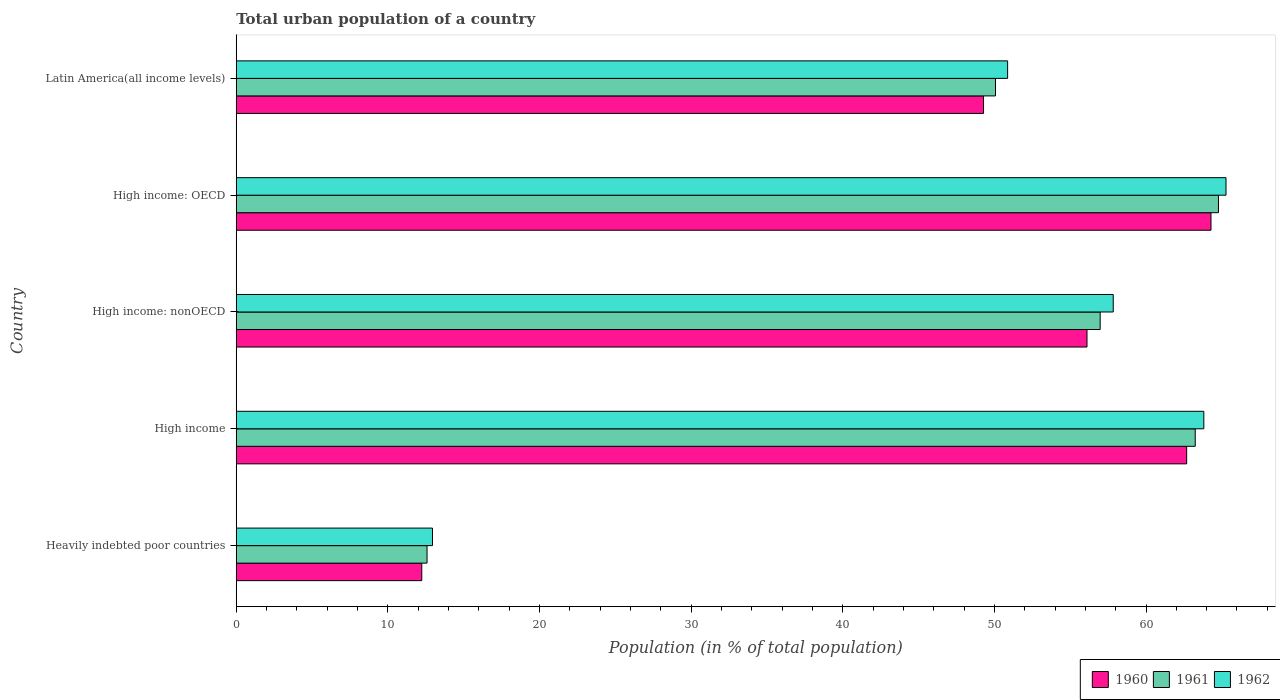How many groups of bars are there?
Offer a terse response. 5. Are the number of bars per tick equal to the number of legend labels?
Ensure brevity in your answer.  Yes. How many bars are there on the 1st tick from the top?
Offer a very short reply. 3. What is the label of the 2nd group of bars from the top?
Keep it short and to the point. High income: OECD. In how many cases, is the number of bars for a given country not equal to the number of legend labels?
Your answer should be compact. 0. What is the urban population in 1962 in Latin America(all income levels)?
Provide a short and direct response. 50.87. Across all countries, what is the maximum urban population in 1961?
Keep it short and to the point. 64.78. Across all countries, what is the minimum urban population in 1961?
Your response must be concise. 12.58. In which country was the urban population in 1960 maximum?
Provide a succinct answer. High income: OECD. In which country was the urban population in 1962 minimum?
Your answer should be very brief. Heavily indebted poor countries. What is the total urban population in 1960 in the graph?
Make the answer very short. 244.59. What is the difference between the urban population in 1961 in High income: nonOECD and that in Latin America(all income levels)?
Give a very brief answer. 6.9. What is the difference between the urban population in 1962 in Heavily indebted poor countries and the urban population in 1960 in High income: nonOECD?
Ensure brevity in your answer.  -43.17. What is the average urban population in 1961 per country?
Your response must be concise. 49.53. What is the difference between the urban population in 1962 and urban population in 1961 in High income: OECD?
Your answer should be very brief. 0.5. What is the ratio of the urban population in 1961 in Heavily indebted poor countries to that in Latin America(all income levels)?
Give a very brief answer. 0.25. Is the urban population in 1960 in High income less than that in High income: OECD?
Ensure brevity in your answer.  Yes. What is the difference between the highest and the second highest urban population in 1960?
Provide a short and direct response. 1.61. What is the difference between the highest and the lowest urban population in 1961?
Provide a short and direct response. 52.2. Is the sum of the urban population in 1962 in Heavily indebted poor countries and High income: nonOECD greater than the maximum urban population in 1960 across all countries?
Offer a very short reply. Yes. Is it the case that in every country, the sum of the urban population in 1962 and urban population in 1960 is greater than the urban population in 1961?
Provide a short and direct response. Yes. Are all the bars in the graph horizontal?
Offer a very short reply. Yes. How many countries are there in the graph?
Provide a short and direct response. 5. Are the values on the major ticks of X-axis written in scientific E-notation?
Ensure brevity in your answer.  No. Does the graph contain grids?
Your answer should be compact. No. Where does the legend appear in the graph?
Offer a very short reply. Bottom right. What is the title of the graph?
Keep it short and to the point. Total urban population of a country. What is the label or title of the X-axis?
Provide a short and direct response. Population (in % of total population). What is the label or title of the Y-axis?
Your answer should be compact. Country. What is the Population (in % of total population) of 1960 in Heavily indebted poor countries?
Give a very brief answer. 12.24. What is the Population (in % of total population) of 1961 in Heavily indebted poor countries?
Provide a short and direct response. 12.58. What is the Population (in % of total population) of 1962 in Heavily indebted poor countries?
Your answer should be very brief. 12.94. What is the Population (in % of total population) of 1960 in High income?
Offer a very short reply. 62.68. What is the Population (in % of total population) in 1961 in High income?
Keep it short and to the point. 63.25. What is the Population (in % of total population) in 1962 in High income?
Ensure brevity in your answer.  63.81. What is the Population (in % of total population) in 1960 in High income: nonOECD?
Offer a very short reply. 56.11. What is the Population (in % of total population) of 1961 in High income: nonOECD?
Your answer should be compact. 56.98. What is the Population (in % of total population) in 1962 in High income: nonOECD?
Your response must be concise. 57.84. What is the Population (in % of total population) of 1960 in High income: OECD?
Provide a short and direct response. 64.29. What is the Population (in % of total population) of 1961 in High income: OECD?
Make the answer very short. 64.78. What is the Population (in % of total population) of 1962 in High income: OECD?
Offer a very short reply. 65.28. What is the Population (in % of total population) of 1960 in Latin America(all income levels)?
Provide a short and direct response. 49.28. What is the Population (in % of total population) in 1961 in Latin America(all income levels)?
Make the answer very short. 50.07. What is the Population (in % of total population) of 1962 in Latin America(all income levels)?
Offer a terse response. 50.87. Across all countries, what is the maximum Population (in % of total population) in 1960?
Ensure brevity in your answer.  64.29. Across all countries, what is the maximum Population (in % of total population) of 1961?
Offer a terse response. 64.78. Across all countries, what is the maximum Population (in % of total population) in 1962?
Ensure brevity in your answer.  65.28. Across all countries, what is the minimum Population (in % of total population) in 1960?
Ensure brevity in your answer.  12.24. Across all countries, what is the minimum Population (in % of total population) of 1961?
Your answer should be very brief. 12.58. Across all countries, what is the minimum Population (in % of total population) of 1962?
Give a very brief answer. 12.94. What is the total Population (in % of total population) of 1960 in the graph?
Offer a terse response. 244.59. What is the total Population (in % of total population) in 1961 in the graph?
Give a very brief answer. 247.66. What is the total Population (in % of total population) in 1962 in the graph?
Make the answer very short. 250.74. What is the difference between the Population (in % of total population) of 1960 in Heavily indebted poor countries and that in High income?
Provide a short and direct response. -50.44. What is the difference between the Population (in % of total population) of 1961 in Heavily indebted poor countries and that in High income?
Your answer should be very brief. -50.66. What is the difference between the Population (in % of total population) in 1962 in Heavily indebted poor countries and that in High income?
Ensure brevity in your answer.  -50.87. What is the difference between the Population (in % of total population) of 1960 in Heavily indebted poor countries and that in High income: nonOECD?
Provide a short and direct response. -43.87. What is the difference between the Population (in % of total population) of 1961 in Heavily indebted poor countries and that in High income: nonOECD?
Offer a terse response. -44.39. What is the difference between the Population (in % of total population) in 1962 in Heavily indebted poor countries and that in High income: nonOECD?
Your answer should be very brief. -44.9. What is the difference between the Population (in % of total population) in 1960 in Heavily indebted poor countries and that in High income: OECD?
Make the answer very short. -52.05. What is the difference between the Population (in % of total population) of 1961 in Heavily indebted poor countries and that in High income: OECD?
Your response must be concise. -52.2. What is the difference between the Population (in % of total population) in 1962 in Heavily indebted poor countries and that in High income: OECD?
Make the answer very short. -52.33. What is the difference between the Population (in % of total population) of 1960 in Heavily indebted poor countries and that in Latin America(all income levels)?
Offer a terse response. -37.05. What is the difference between the Population (in % of total population) in 1961 in Heavily indebted poor countries and that in Latin America(all income levels)?
Your answer should be very brief. -37.49. What is the difference between the Population (in % of total population) of 1962 in Heavily indebted poor countries and that in Latin America(all income levels)?
Keep it short and to the point. -37.93. What is the difference between the Population (in % of total population) of 1960 in High income and that in High income: nonOECD?
Offer a very short reply. 6.57. What is the difference between the Population (in % of total population) in 1961 in High income and that in High income: nonOECD?
Keep it short and to the point. 6.27. What is the difference between the Population (in % of total population) in 1962 in High income and that in High income: nonOECD?
Offer a terse response. 5.97. What is the difference between the Population (in % of total population) in 1960 in High income and that in High income: OECD?
Give a very brief answer. -1.61. What is the difference between the Population (in % of total population) of 1961 in High income and that in High income: OECD?
Make the answer very short. -1.53. What is the difference between the Population (in % of total population) in 1962 in High income and that in High income: OECD?
Make the answer very short. -1.46. What is the difference between the Population (in % of total population) of 1960 in High income and that in Latin America(all income levels)?
Make the answer very short. 13.4. What is the difference between the Population (in % of total population) in 1961 in High income and that in Latin America(all income levels)?
Give a very brief answer. 13.17. What is the difference between the Population (in % of total population) of 1962 in High income and that in Latin America(all income levels)?
Give a very brief answer. 12.94. What is the difference between the Population (in % of total population) of 1960 in High income: nonOECD and that in High income: OECD?
Your answer should be very brief. -8.18. What is the difference between the Population (in % of total population) in 1961 in High income: nonOECD and that in High income: OECD?
Provide a short and direct response. -7.8. What is the difference between the Population (in % of total population) in 1962 in High income: nonOECD and that in High income: OECD?
Ensure brevity in your answer.  -7.44. What is the difference between the Population (in % of total population) of 1960 in High income: nonOECD and that in Latin America(all income levels)?
Your response must be concise. 6.82. What is the difference between the Population (in % of total population) of 1961 in High income: nonOECD and that in Latin America(all income levels)?
Your answer should be very brief. 6.9. What is the difference between the Population (in % of total population) in 1962 in High income: nonOECD and that in Latin America(all income levels)?
Provide a succinct answer. 6.97. What is the difference between the Population (in % of total population) of 1960 in High income: OECD and that in Latin America(all income levels)?
Your response must be concise. 15. What is the difference between the Population (in % of total population) in 1961 in High income: OECD and that in Latin America(all income levels)?
Ensure brevity in your answer.  14.71. What is the difference between the Population (in % of total population) in 1962 in High income: OECD and that in Latin America(all income levels)?
Give a very brief answer. 14.4. What is the difference between the Population (in % of total population) of 1960 in Heavily indebted poor countries and the Population (in % of total population) of 1961 in High income?
Keep it short and to the point. -51.01. What is the difference between the Population (in % of total population) of 1960 in Heavily indebted poor countries and the Population (in % of total population) of 1962 in High income?
Your answer should be very brief. -51.58. What is the difference between the Population (in % of total population) in 1961 in Heavily indebted poor countries and the Population (in % of total population) in 1962 in High income?
Provide a succinct answer. -51.23. What is the difference between the Population (in % of total population) in 1960 in Heavily indebted poor countries and the Population (in % of total population) in 1961 in High income: nonOECD?
Make the answer very short. -44.74. What is the difference between the Population (in % of total population) of 1960 in Heavily indebted poor countries and the Population (in % of total population) of 1962 in High income: nonOECD?
Offer a very short reply. -45.6. What is the difference between the Population (in % of total population) in 1961 in Heavily indebted poor countries and the Population (in % of total population) in 1962 in High income: nonOECD?
Make the answer very short. -45.26. What is the difference between the Population (in % of total population) in 1960 in Heavily indebted poor countries and the Population (in % of total population) in 1961 in High income: OECD?
Give a very brief answer. -52.54. What is the difference between the Population (in % of total population) of 1960 in Heavily indebted poor countries and the Population (in % of total population) of 1962 in High income: OECD?
Ensure brevity in your answer.  -53.04. What is the difference between the Population (in % of total population) of 1961 in Heavily indebted poor countries and the Population (in % of total population) of 1962 in High income: OECD?
Your answer should be compact. -52.69. What is the difference between the Population (in % of total population) in 1960 in Heavily indebted poor countries and the Population (in % of total population) in 1961 in Latin America(all income levels)?
Provide a succinct answer. -37.84. What is the difference between the Population (in % of total population) of 1960 in Heavily indebted poor countries and the Population (in % of total population) of 1962 in Latin America(all income levels)?
Keep it short and to the point. -38.64. What is the difference between the Population (in % of total population) in 1961 in Heavily indebted poor countries and the Population (in % of total population) in 1962 in Latin America(all income levels)?
Offer a very short reply. -38.29. What is the difference between the Population (in % of total population) in 1960 in High income and the Population (in % of total population) in 1961 in High income: nonOECD?
Your response must be concise. 5.7. What is the difference between the Population (in % of total population) in 1960 in High income and the Population (in % of total population) in 1962 in High income: nonOECD?
Your response must be concise. 4.84. What is the difference between the Population (in % of total population) of 1961 in High income and the Population (in % of total population) of 1962 in High income: nonOECD?
Provide a short and direct response. 5.41. What is the difference between the Population (in % of total population) of 1960 in High income and the Population (in % of total population) of 1961 in High income: OECD?
Keep it short and to the point. -2.1. What is the difference between the Population (in % of total population) in 1960 in High income and the Population (in % of total population) in 1962 in High income: OECD?
Give a very brief answer. -2.6. What is the difference between the Population (in % of total population) of 1961 in High income and the Population (in % of total population) of 1962 in High income: OECD?
Provide a short and direct response. -2.03. What is the difference between the Population (in % of total population) of 1960 in High income and the Population (in % of total population) of 1961 in Latin America(all income levels)?
Ensure brevity in your answer.  12.61. What is the difference between the Population (in % of total population) in 1960 in High income and the Population (in % of total population) in 1962 in Latin America(all income levels)?
Provide a succinct answer. 11.81. What is the difference between the Population (in % of total population) of 1961 in High income and the Population (in % of total population) of 1962 in Latin America(all income levels)?
Ensure brevity in your answer.  12.37. What is the difference between the Population (in % of total population) in 1960 in High income: nonOECD and the Population (in % of total population) in 1961 in High income: OECD?
Provide a short and direct response. -8.67. What is the difference between the Population (in % of total population) in 1960 in High income: nonOECD and the Population (in % of total population) in 1962 in High income: OECD?
Offer a very short reply. -9.17. What is the difference between the Population (in % of total population) of 1961 in High income: nonOECD and the Population (in % of total population) of 1962 in High income: OECD?
Ensure brevity in your answer.  -8.3. What is the difference between the Population (in % of total population) of 1960 in High income: nonOECD and the Population (in % of total population) of 1961 in Latin America(all income levels)?
Offer a terse response. 6.03. What is the difference between the Population (in % of total population) of 1960 in High income: nonOECD and the Population (in % of total population) of 1962 in Latin America(all income levels)?
Offer a terse response. 5.24. What is the difference between the Population (in % of total population) in 1961 in High income: nonOECD and the Population (in % of total population) in 1962 in Latin America(all income levels)?
Give a very brief answer. 6.1. What is the difference between the Population (in % of total population) in 1960 in High income: OECD and the Population (in % of total population) in 1961 in Latin America(all income levels)?
Offer a very short reply. 14.21. What is the difference between the Population (in % of total population) in 1960 in High income: OECD and the Population (in % of total population) in 1962 in Latin America(all income levels)?
Provide a short and direct response. 13.41. What is the difference between the Population (in % of total population) in 1961 in High income: OECD and the Population (in % of total population) in 1962 in Latin America(all income levels)?
Make the answer very short. 13.91. What is the average Population (in % of total population) of 1960 per country?
Make the answer very short. 48.92. What is the average Population (in % of total population) in 1961 per country?
Ensure brevity in your answer.  49.53. What is the average Population (in % of total population) of 1962 per country?
Make the answer very short. 50.15. What is the difference between the Population (in % of total population) of 1960 and Population (in % of total population) of 1961 in Heavily indebted poor countries?
Provide a succinct answer. -0.35. What is the difference between the Population (in % of total population) of 1960 and Population (in % of total population) of 1962 in Heavily indebted poor countries?
Your response must be concise. -0.71. What is the difference between the Population (in % of total population) of 1961 and Population (in % of total population) of 1962 in Heavily indebted poor countries?
Offer a very short reply. -0.36. What is the difference between the Population (in % of total population) in 1960 and Population (in % of total population) in 1961 in High income?
Make the answer very short. -0.57. What is the difference between the Population (in % of total population) of 1960 and Population (in % of total population) of 1962 in High income?
Give a very brief answer. -1.13. What is the difference between the Population (in % of total population) in 1961 and Population (in % of total population) in 1962 in High income?
Keep it short and to the point. -0.57. What is the difference between the Population (in % of total population) of 1960 and Population (in % of total population) of 1961 in High income: nonOECD?
Provide a succinct answer. -0.87. What is the difference between the Population (in % of total population) of 1960 and Population (in % of total population) of 1962 in High income: nonOECD?
Give a very brief answer. -1.73. What is the difference between the Population (in % of total population) of 1961 and Population (in % of total population) of 1962 in High income: nonOECD?
Provide a short and direct response. -0.86. What is the difference between the Population (in % of total population) of 1960 and Population (in % of total population) of 1961 in High income: OECD?
Provide a short and direct response. -0.49. What is the difference between the Population (in % of total population) of 1960 and Population (in % of total population) of 1962 in High income: OECD?
Offer a very short reply. -0.99. What is the difference between the Population (in % of total population) of 1961 and Population (in % of total population) of 1962 in High income: OECD?
Your answer should be very brief. -0.5. What is the difference between the Population (in % of total population) of 1960 and Population (in % of total population) of 1961 in Latin America(all income levels)?
Make the answer very short. -0.79. What is the difference between the Population (in % of total population) in 1960 and Population (in % of total population) in 1962 in Latin America(all income levels)?
Make the answer very short. -1.59. What is the difference between the Population (in % of total population) of 1961 and Population (in % of total population) of 1962 in Latin America(all income levels)?
Your answer should be very brief. -0.8. What is the ratio of the Population (in % of total population) of 1960 in Heavily indebted poor countries to that in High income?
Ensure brevity in your answer.  0.2. What is the ratio of the Population (in % of total population) in 1961 in Heavily indebted poor countries to that in High income?
Provide a succinct answer. 0.2. What is the ratio of the Population (in % of total population) in 1962 in Heavily indebted poor countries to that in High income?
Offer a very short reply. 0.2. What is the ratio of the Population (in % of total population) in 1960 in Heavily indebted poor countries to that in High income: nonOECD?
Keep it short and to the point. 0.22. What is the ratio of the Population (in % of total population) in 1961 in Heavily indebted poor countries to that in High income: nonOECD?
Offer a terse response. 0.22. What is the ratio of the Population (in % of total population) in 1962 in Heavily indebted poor countries to that in High income: nonOECD?
Make the answer very short. 0.22. What is the ratio of the Population (in % of total population) of 1960 in Heavily indebted poor countries to that in High income: OECD?
Keep it short and to the point. 0.19. What is the ratio of the Population (in % of total population) in 1961 in Heavily indebted poor countries to that in High income: OECD?
Keep it short and to the point. 0.19. What is the ratio of the Population (in % of total population) of 1962 in Heavily indebted poor countries to that in High income: OECD?
Offer a very short reply. 0.2. What is the ratio of the Population (in % of total population) of 1960 in Heavily indebted poor countries to that in Latin America(all income levels)?
Provide a short and direct response. 0.25. What is the ratio of the Population (in % of total population) of 1961 in Heavily indebted poor countries to that in Latin America(all income levels)?
Make the answer very short. 0.25. What is the ratio of the Population (in % of total population) in 1962 in Heavily indebted poor countries to that in Latin America(all income levels)?
Provide a succinct answer. 0.25. What is the ratio of the Population (in % of total population) in 1960 in High income to that in High income: nonOECD?
Provide a succinct answer. 1.12. What is the ratio of the Population (in % of total population) in 1961 in High income to that in High income: nonOECD?
Your answer should be compact. 1.11. What is the ratio of the Population (in % of total population) in 1962 in High income to that in High income: nonOECD?
Your answer should be compact. 1.1. What is the ratio of the Population (in % of total population) in 1960 in High income to that in High income: OECD?
Make the answer very short. 0.97. What is the ratio of the Population (in % of total population) in 1961 in High income to that in High income: OECD?
Your response must be concise. 0.98. What is the ratio of the Population (in % of total population) in 1962 in High income to that in High income: OECD?
Your response must be concise. 0.98. What is the ratio of the Population (in % of total population) in 1960 in High income to that in Latin America(all income levels)?
Offer a terse response. 1.27. What is the ratio of the Population (in % of total population) of 1961 in High income to that in Latin America(all income levels)?
Your answer should be compact. 1.26. What is the ratio of the Population (in % of total population) in 1962 in High income to that in Latin America(all income levels)?
Your response must be concise. 1.25. What is the ratio of the Population (in % of total population) in 1960 in High income: nonOECD to that in High income: OECD?
Ensure brevity in your answer.  0.87. What is the ratio of the Population (in % of total population) in 1961 in High income: nonOECD to that in High income: OECD?
Give a very brief answer. 0.88. What is the ratio of the Population (in % of total population) in 1962 in High income: nonOECD to that in High income: OECD?
Offer a very short reply. 0.89. What is the ratio of the Population (in % of total population) of 1960 in High income: nonOECD to that in Latin America(all income levels)?
Your answer should be compact. 1.14. What is the ratio of the Population (in % of total population) in 1961 in High income: nonOECD to that in Latin America(all income levels)?
Provide a succinct answer. 1.14. What is the ratio of the Population (in % of total population) of 1962 in High income: nonOECD to that in Latin America(all income levels)?
Make the answer very short. 1.14. What is the ratio of the Population (in % of total population) of 1960 in High income: OECD to that in Latin America(all income levels)?
Give a very brief answer. 1.3. What is the ratio of the Population (in % of total population) of 1961 in High income: OECD to that in Latin America(all income levels)?
Ensure brevity in your answer.  1.29. What is the ratio of the Population (in % of total population) of 1962 in High income: OECD to that in Latin America(all income levels)?
Provide a succinct answer. 1.28. What is the difference between the highest and the second highest Population (in % of total population) in 1960?
Give a very brief answer. 1.61. What is the difference between the highest and the second highest Population (in % of total population) in 1961?
Provide a succinct answer. 1.53. What is the difference between the highest and the second highest Population (in % of total population) in 1962?
Provide a succinct answer. 1.46. What is the difference between the highest and the lowest Population (in % of total population) of 1960?
Your response must be concise. 52.05. What is the difference between the highest and the lowest Population (in % of total population) of 1961?
Provide a succinct answer. 52.2. What is the difference between the highest and the lowest Population (in % of total population) of 1962?
Provide a succinct answer. 52.33. 